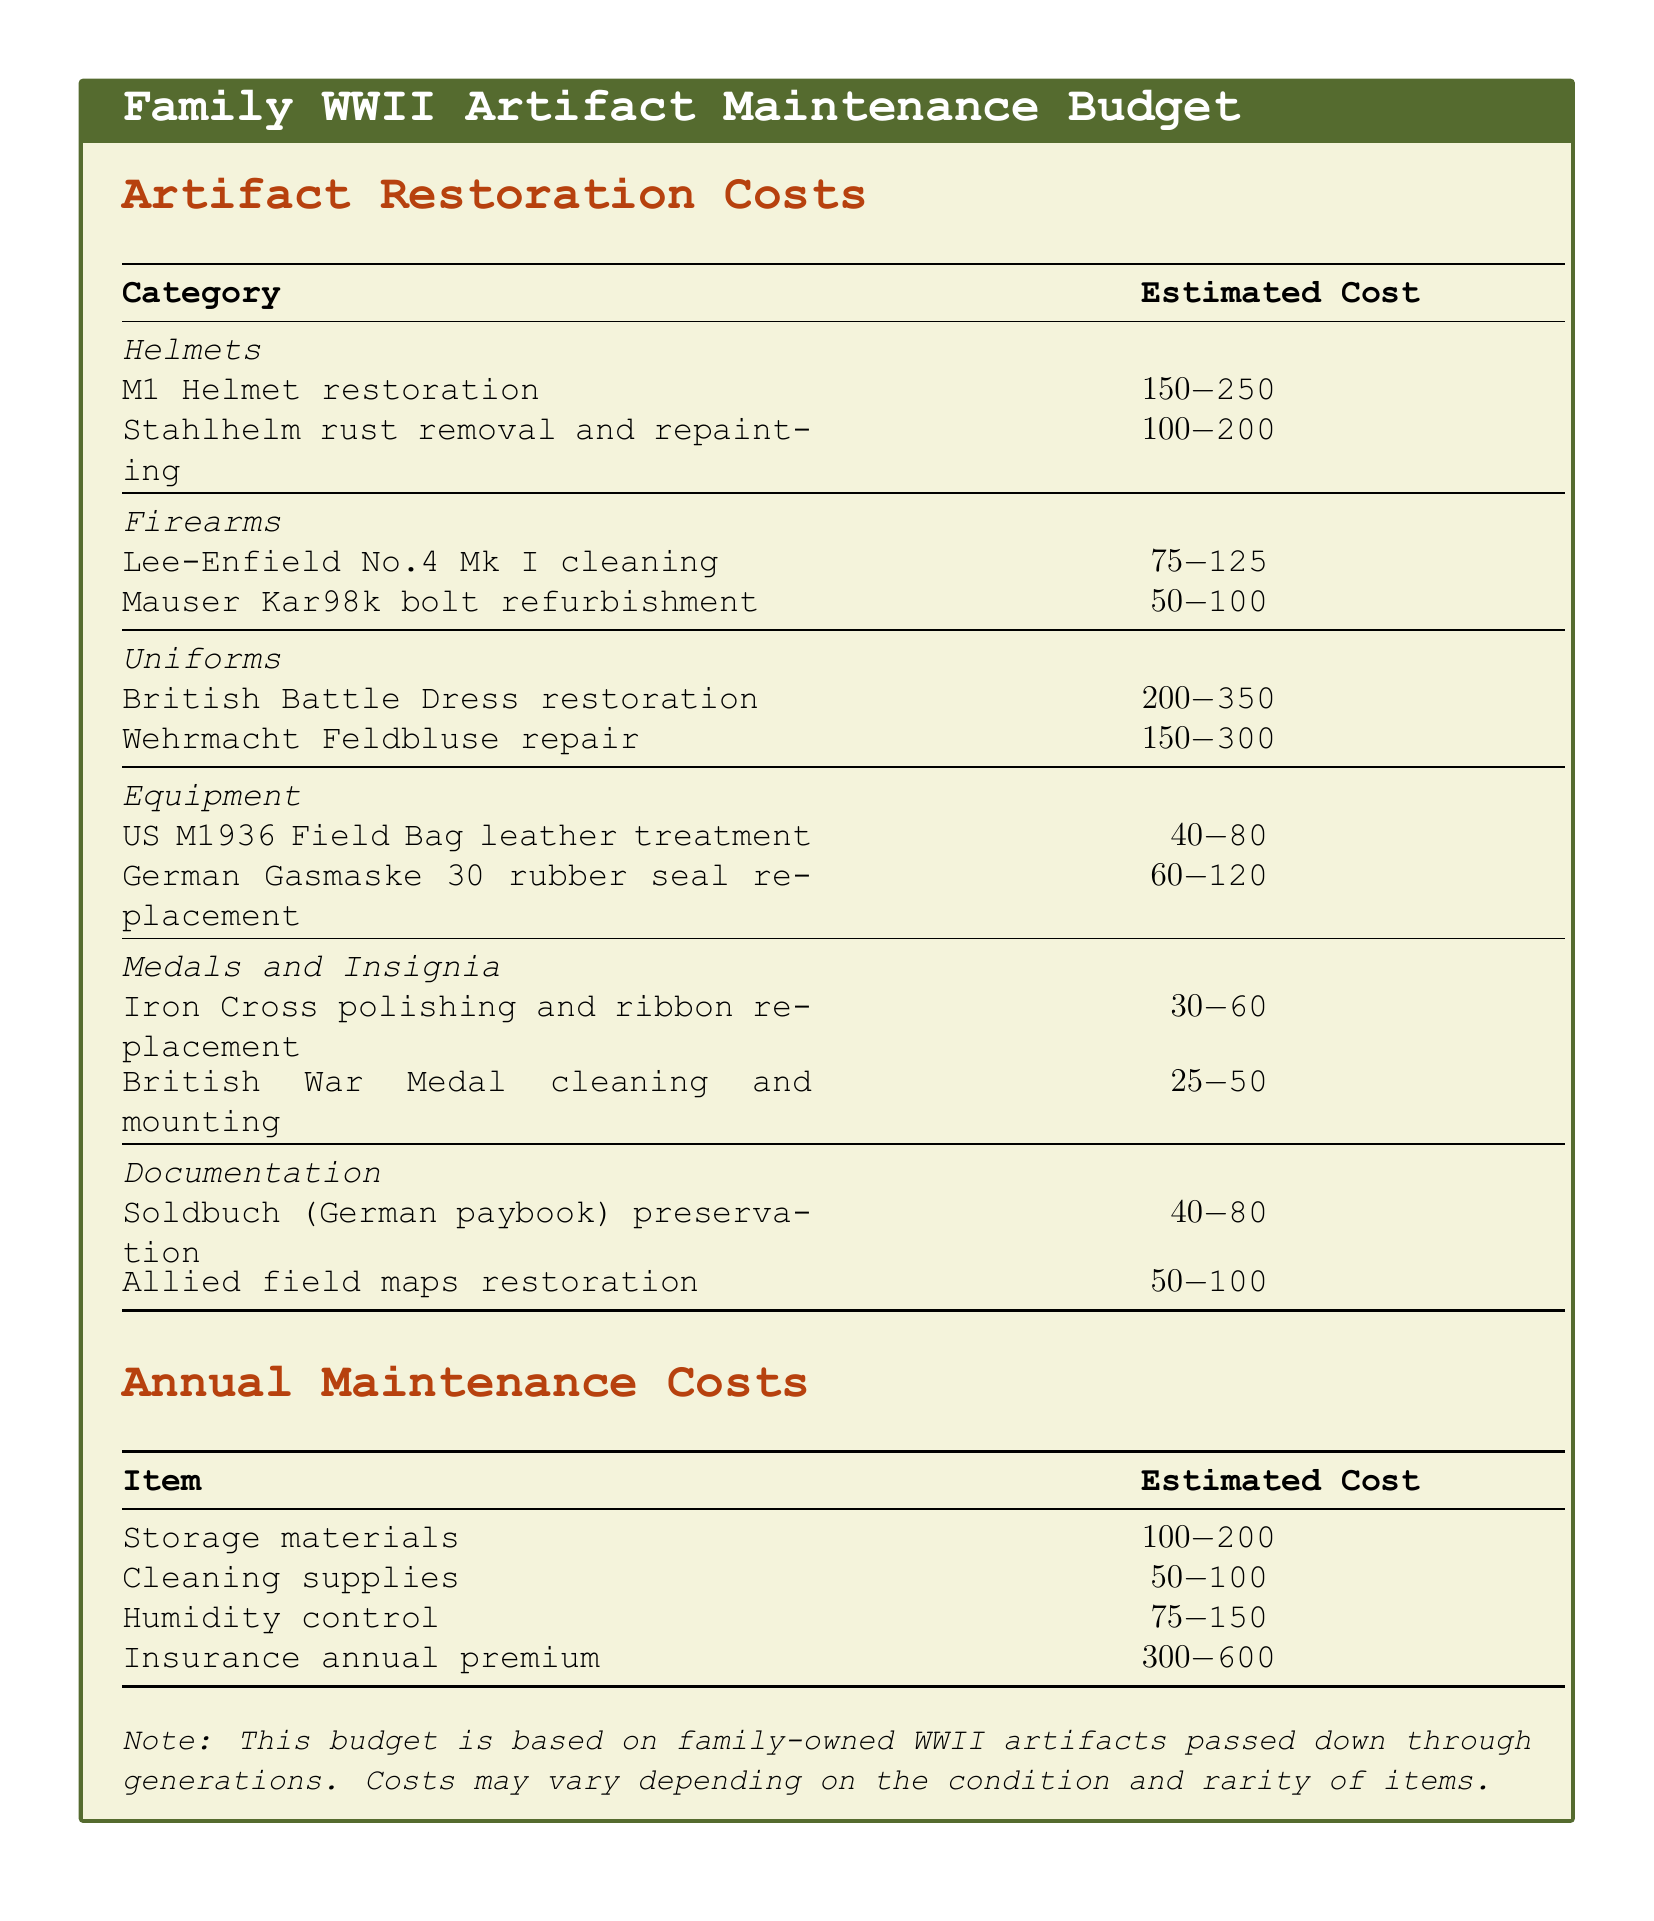what is the estimated cost range for restoring an M1 Helmet? The document specifies the cost range for M1 Helmet restoration as $150 to $250.
Answer: $150-$250 how much does it cost to clean a Lee-Enfield No.4 Mk I? The document cites the estimated cost for cleaning a Lee-Enfield No.4 Mk I as $75 to $125.
Answer: $75-$125 what is the highest estimated cost for uniform restoration? The British Battle Dress restoration has the highest estimated cost at $200 to $350 among the uniform restorations listed.
Answer: $200-$350 how much is the estimated annual premium for insurance? The document indicates that the annual premium for insurance ranges from $300 to $600.
Answer: $300-$600 what is the estimated cost for the replacement of the rubber seal for the German Gasmaske 30? The estimated cost for the replacement of the rubber seal for the German Gasmaske 30 is between $60 and $120.
Answer: $60-$120 which category includes the lowest estimated cost item? The Medals and Insignia category includes the lowest estimated cost item, which is the British War Medal cleaning and mounting.
Answer: British War Medal cleaning and mounting what is the total estimated cost for restoring the helmets? The total estimated cost for restoring helmets is $150-$250 + $100-$200 = $250-$450.
Answer: $250-$450 how much can one expect to spend annually on cleaning supplies? The document outlines that the estimated cost for cleaning supplies is between $50 and $100 annually.
Answer: $50-$100 